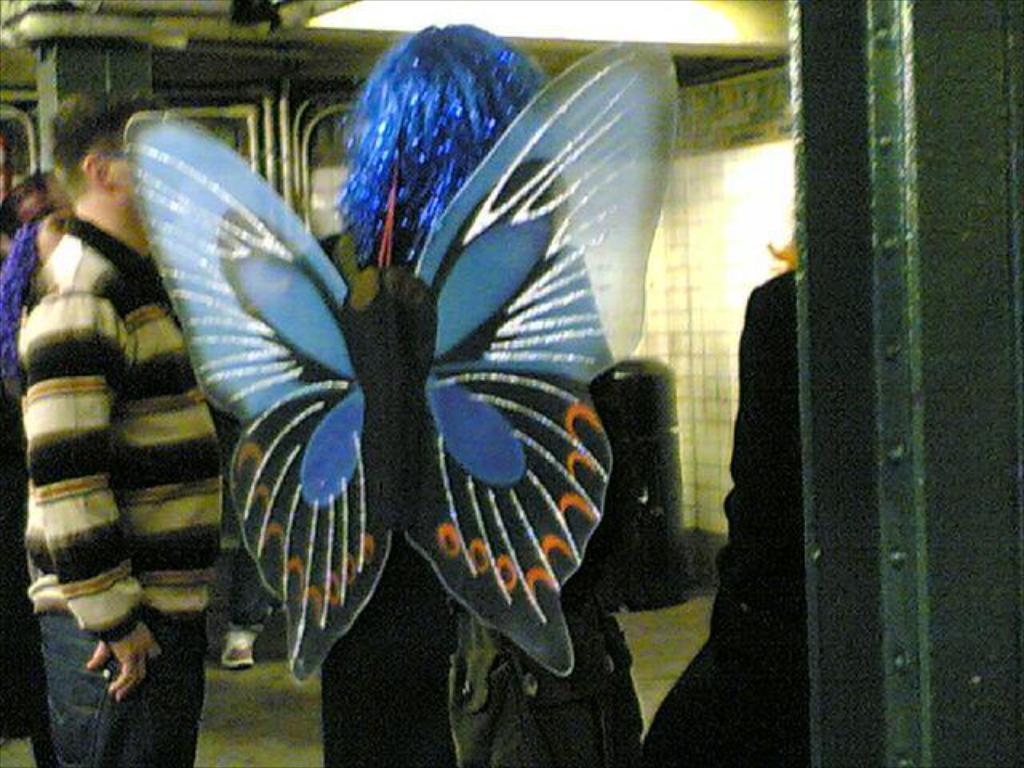Please provide a concise description of this image. In the center of the image we can see a person wearing the bag and also the fancy costume. We can also see the people standing. We can see the wall, pillar. 